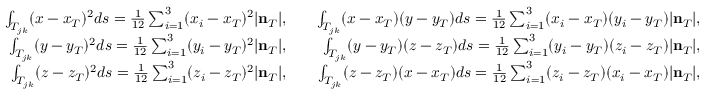<formula> <loc_0><loc_0><loc_500><loc_500>\begin{array} { r l r } { \int _ { T _ { j k } } ( x - x _ { T } ) ^ { 2 } d s = \frac { 1 } { 1 2 } \sum _ { i = 1 } ^ { 3 } ( x _ { i } - x _ { T } ) ^ { 2 } | { n } _ { T } | , } & { \int _ { T _ { j k } } ( x - x _ { T } ) ( y - y _ { T } ) d s = \frac { 1 } { 1 2 } \sum _ { i = 1 } ^ { 3 } ( x _ { i } - x _ { T } ) ( y _ { i } - y _ { T } ) | { n } _ { T } | , } \\ { \int _ { T _ { j k } } ( y - y _ { T } ) ^ { 2 } d s = \frac { 1 } { 1 2 } \sum _ { i = 1 } ^ { 3 } ( y _ { i } - y _ { T } ) ^ { 2 } | { n } _ { T } | , } & { \int _ { T _ { j k } } ( y - y _ { T } ) ( z - z _ { T } ) d s = \frac { 1 } { 1 2 } \sum _ { i = 1 } ^ { 3 } ( y _ { i } - y _ { T } ) ( z _ { i } - z _ { T } ) | { n } _ { T } | , } \\ { \int _ { T _ { j k } } ( z - z _ { T } ) ^ { 2 } d s = \frac { 1 } { 1 2 } \sum _ { i = 1 } ^ { 3 } ( z _ { i } - z _ { T } ) ^ { 2 } | { n } _ { T } | , } & { \int _ { T _ { j k } } ( z - z _ { T } ) ( x - x _ { T } ) d s = \frac { 1 } { 1 2 } \sum _ { i = 1 } ^ { 3 } ( z _ { i } - z _ { T } ) ( x _ { i } - x _ { T } ) | { n } _ { T } | , } \end{array}</formula> 